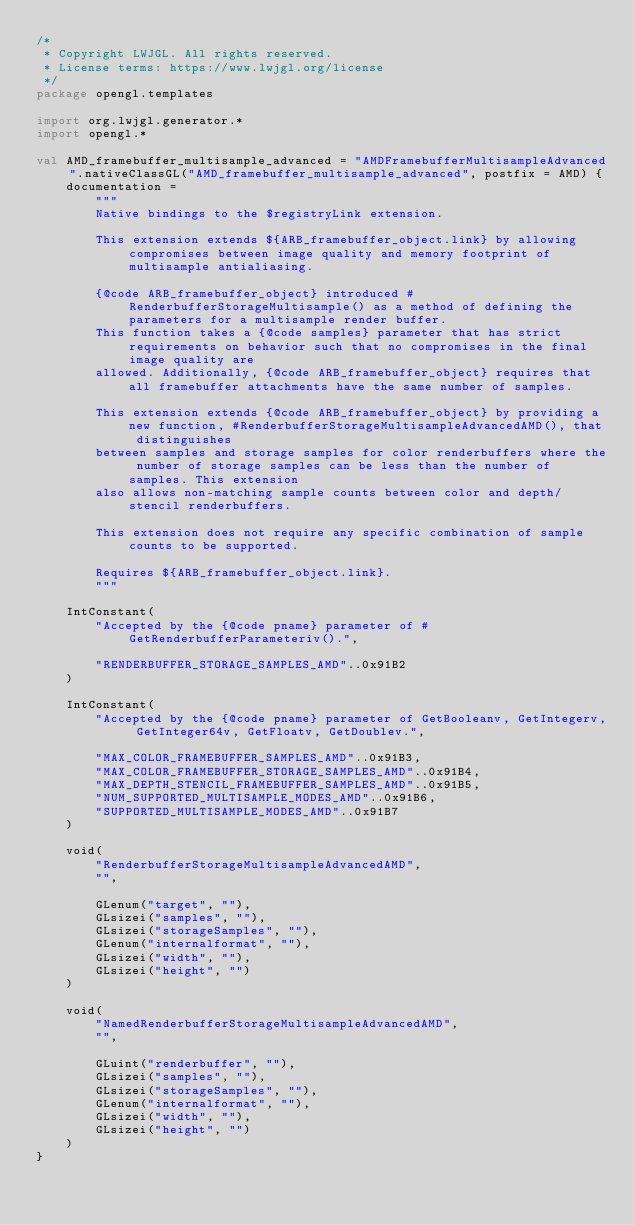<code> <loc_0><loc_0><loc_500><loc_500><_Kotlin_>/*
 * Copyright LWJGL. All rights reserved.
 * License terms: https://www.lwjgl.org/license
 */
package opengl.templates

import org.lwjgl.generator.*
import opengl.*

val AMD_framebuffer_multisample_advanced = "AMDFramebufferMultisampleAdvanced".nativeClassGL("AMD_framebuffer_multisample_advanced", postfix = AMD) {
    documentation =
        """
        Native bindings to the $registryLink extension.

        This extension extends ${ARB_framebuffer_object.link} by allowing compromises between image quality and memory footprint of multisample antialiasing.

        {@code ARB_framebuffer_object} introduced #RenderbufferStorageMultisample() as a method of defining the parameters for a multisample render buffer.
        This function takes a {@code samples} parameter that has strict requirements on behavior such that no compromises in the final image quality are
        allowed. Additionally, {@code ARB_framebuffer_object} requires that all framebuffer attachments have the same number of samples.

        This extension extends {@code ARB_framebuffer_object} by providing a new function, #RenderbufferStorageMultisampleAdvancedAMD(), that distinguishes
        between samples and storage samples for color renderbuffers where the number of storage samples can be less than the number of samples. This extension
        also allows non-matching sample counts between color and depth/stencil renderbuffers.

        This extension does not require any specific combination of sample counts to be supported.

        Requires ${ARB_framebuffer_object.link}.
        """

    IntConstant(
        "Accepted by the {@code pname} parameter of #GetRenderbufferParameteriv().",

        "RENDERBUFFER_STORAGE_SAMPLES_AMD"..0x91B2
    )

    IntConstant(
        "Accepted by the {@code pname} parameter of GetBooleanv, GetIntegerv, GetInteger64v, GetFloatv, GetDoublev.",

        "MAX_COLOR_FRAMEBUFFER_SAMPLES_AMD"..0x91B3,
        "MAX_COLOR_FRAMEBUFFER_STORAGE_SAMPLES_AMD"..0x91B4,
        "MAX_DEPTH_STENCIL_FRAMEBUFFER_SAMPLES_AMD"..0x91B5,
        "NUM_SUPPORTED_MULTISAMPLE_MODES_AMD"..0x91B6,
        "SUPPORTED_MULTISAMPLE_MODES_AMD"..0x91B7
    )

    void(
        "RenderbufferStorageMultisampleAdvancedAMD",
        "",

        GLenum("target", ""),
        GLsizei("samples", ""),
        GLsizei("storageSamples", ""),
        GLenum("internalformat", ""),
        GLsizei("width", ""),
        GLsizei("height", "")
    )

    void(
        "NamedRenderbufferStorageMultisampleAdvancedAMD",
        "",

        GLuint("renderbuffer", ""),
        GLsizei("samples", ""),
        GLsizei("storageSamples", ""),
        GLenum("internalformat", ""),
        GLsizei("width", ""),
        GLsizei("height", "")
    )
}</code> 